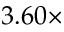<formula> <loc_0><loc_0><loc_500><loc_500>3 . 6 0 \times</formula> 